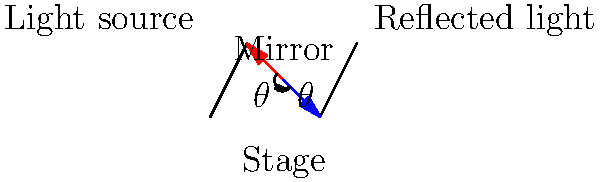In a theatrical production, a stage light is positioned to reflect off an angled mirror onto the stage. If the incident angle of the light beam is 30° to the mirror's normal, what will be the angle of the reflected light beam relative to the stage floor? To solve this problem, we'll use the law of reflection and basic geometry:

1. The law of reflection states that the angle of incidence equals the angle of reflection.

2. Given:
   - Incident angle to mirror's normal = 30°
   - Reflected angle to mirror's normal = 30° (law of reflection)

3. The mirror forms two complementary angles:
   - One with the incident/reflected light
   - One with the stage floor

4. The sum of angles in a right triangle is 90°:
   $$90° = 30° + \text{angle between mirror and stage}$$

5. Solve for the angle between the mirror and stage:
   $$\text{angle between mirror and stage} = 90° - 30° = 60°$$

6. The reflected light forms a right triangle with the stage and mirror:
   - One angle is 90° (perpendicular to stage)
   - One angle is 30° (reflection angle to mirror)
   - The third angle (relative to stage) is what we're seeking

7. Sum of angles in this triangle:
   $$90° + 30° + x = 180°$$
   $$120° + x = 180°$$
   $$x = 60°$$

Therefore, the reflected light beam will be at a 60° angle relative to the stage floor.
Answer: 60° 